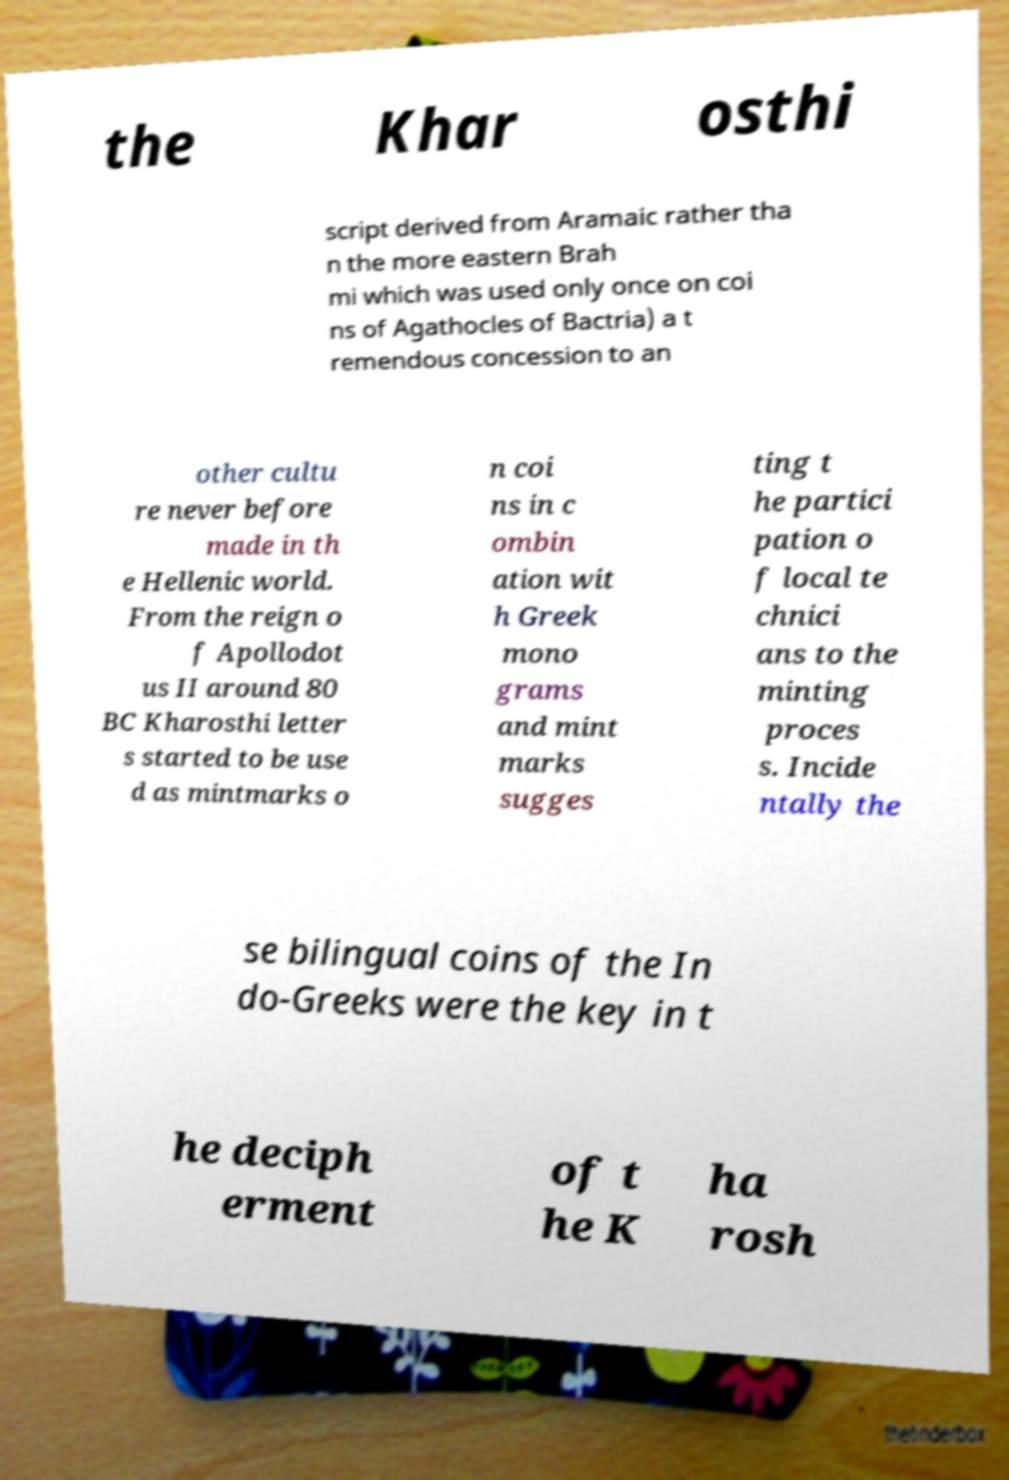Please read and relay the text visible in this image. What does it say? the Khar osthi script derived from Aramaic rather tha n the more eastern Brah mi which was used only once on coi ns of Agathocles of Bactria) a t remendous concession to an other cultu re never before made in th e Hellenic world. From the reign o f Apollodot us II around 80 BC Kharosthi letter s started to be use d as mintmarks o n coi ns in c ombin ation wit h Greek mono grams and mint marks sugges ting t he partici pation o f local te chnici ans to the minting proces s. Incide ntally the se bilingual coins of the In do-Greeks were the key in t he deciph erment of t he K ha rosh 